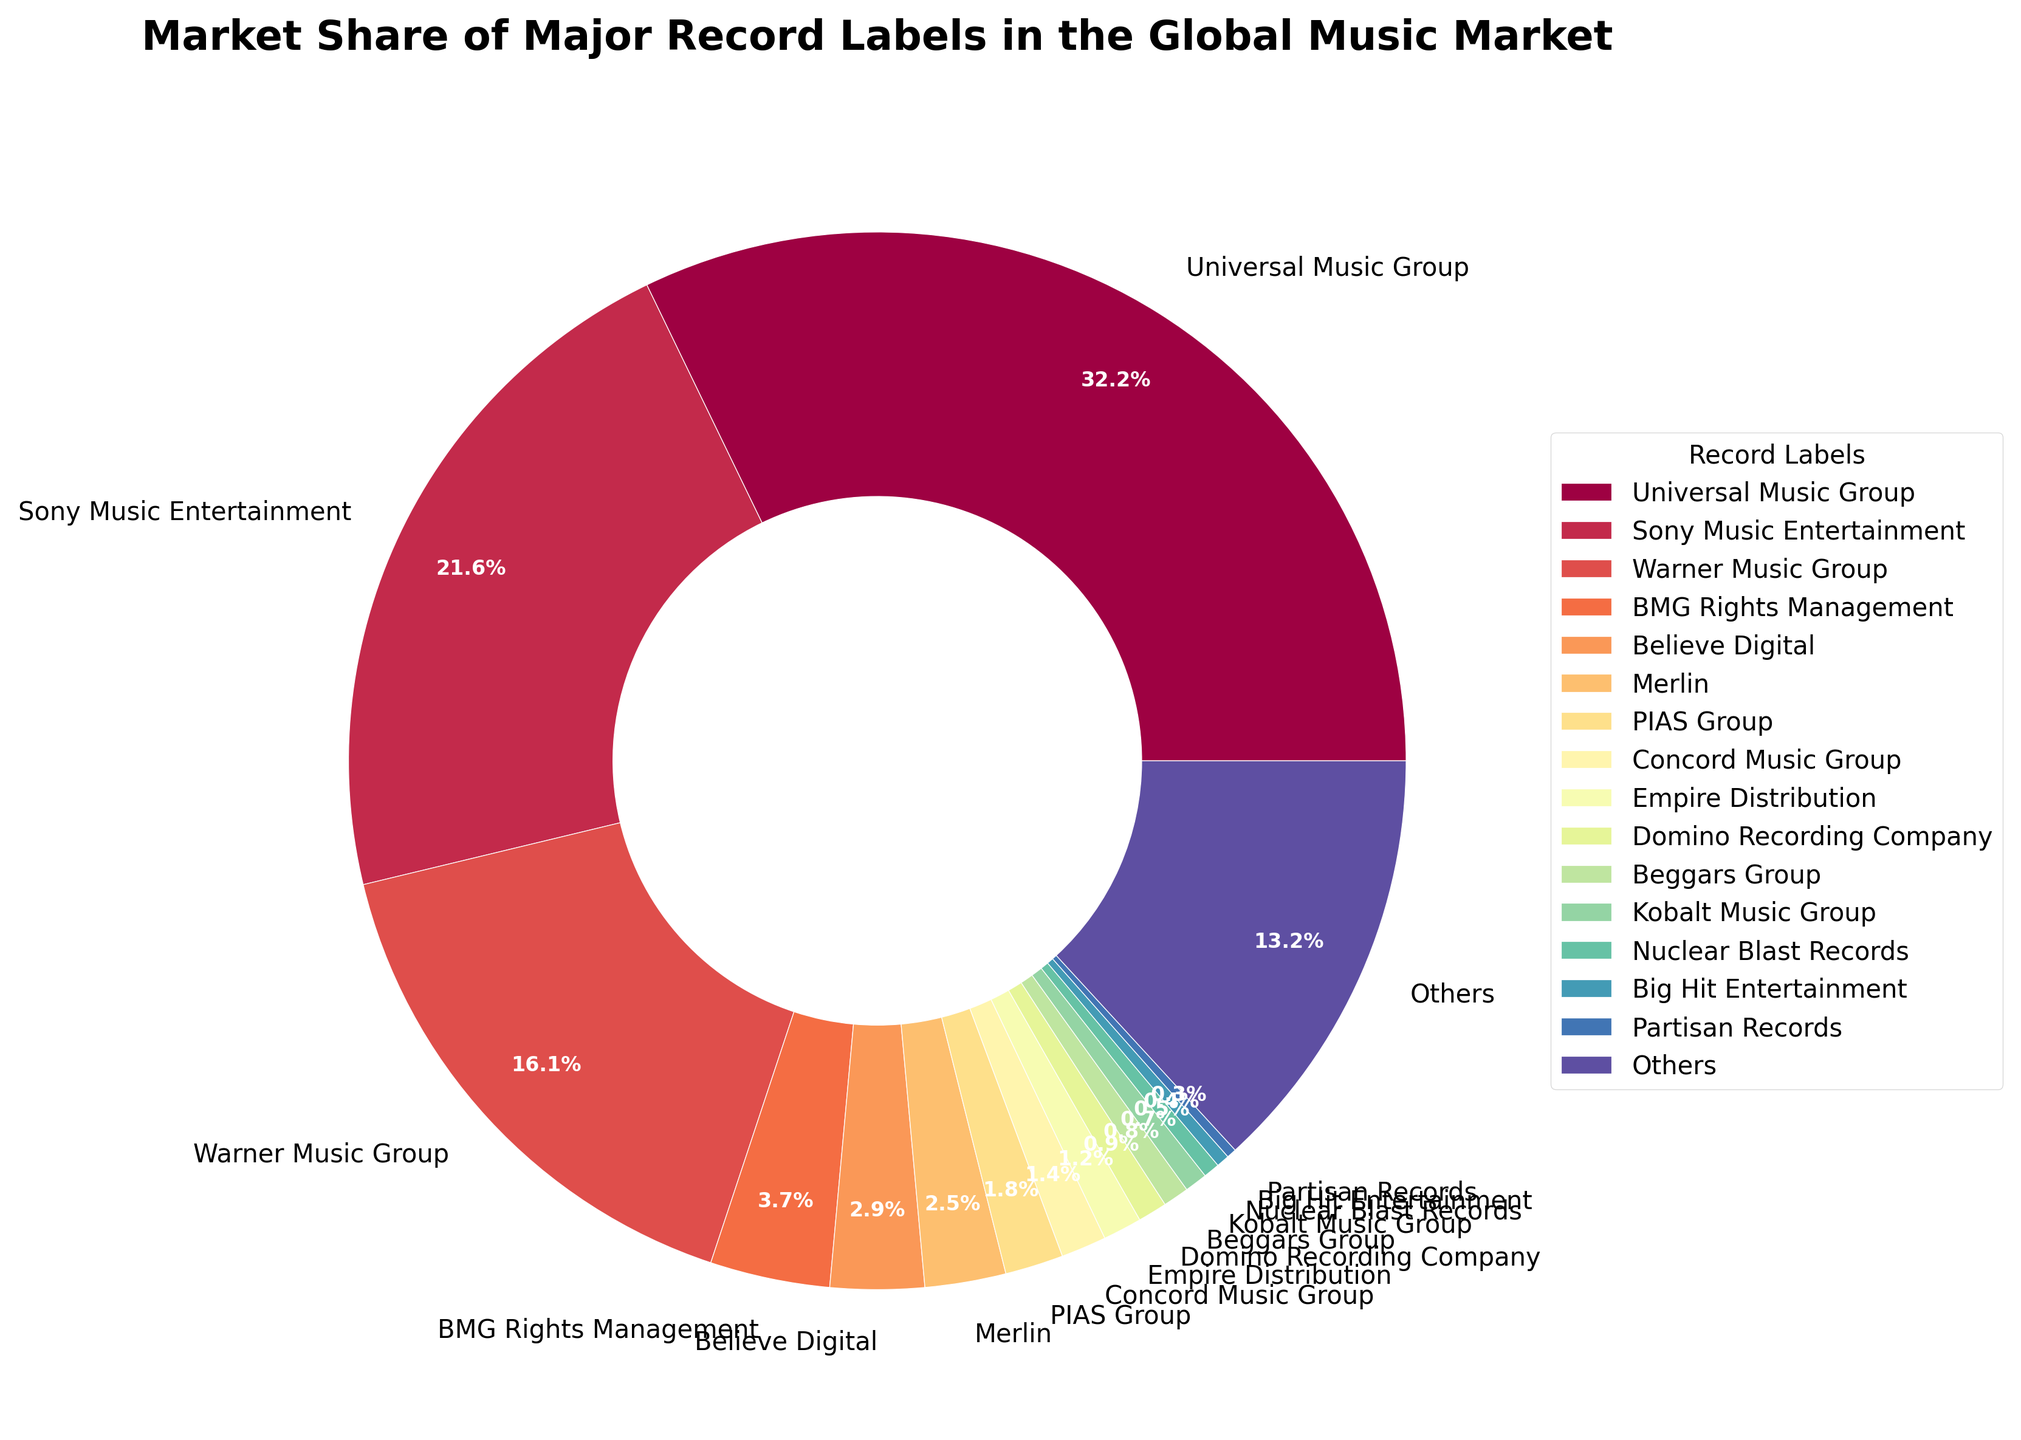What is the market share of the largest record label in the chart? The largest market share is represented by the slice of the pie that is the biggest, which corresponds to Universal Music Group. According to the given data, Universal Music Group has a 32.5% market share.
Answer: 32.5% Which record label has a larger market share: Warner Music Group or Sony Music Entertainment? Visually comparing the sizes of the wedges, the wedge representing Sony Music Entertainment is larger than that of Warner Music Group. According to the data, Sony Music Entertainment has a 21.8% share, and Warner Music Group has a 16.3% share.
Answer: Sony Music Entertainment What is the combined market share of BMG Rights Management and Believe Digital? Adding their market shares together: BMG Rights Management has 3.7% and Believe Digital has 2.9%. So, 3.7 + 2.9 = 6.6%.
Answer: 6.6% How much smaller is the market share of Merlin compared to Warner Music Group? Subtract the market share of Merlin from Warner Music Group: 16.3% - 2.5% = 13.8%.
Answer: 13.8% What percentage of the market do the three largest record labels (Universal Music Group, Sony Music Entertainment, and Warner Music Group) hold collectively? Adding the market shares of these three labels: 32.5% + 21.8% + 16.3% = 70.6%.
Answer: 70.6% Which record label has the smallest market share and what is it? The smallest wedge in the pie chart corresponds to Partisan Records with a market share of 0.3%.
Answer: Partisan Records, 0.3% How does the market share of 'Others' compare to that of BMG Rights Management? Comparing the wedges, 'Others' has a visibly larger market share than BMG Rights Management. 'Others' have a 13.3% market share, while BMG Rights Management has a 3.7% market share.
Answer: Others is larger What is the color of the segment representing Sony Music Entertainment? Each segment of the pie chart is colored differently; the color for Sony Music Entertainment's wedge would be visually identifiable.
Answer: Specific color from the chart (e.g., blue, orange, etc.) What is the average market share of the record labels excluding 'Others'? Summing all the market shares excluding 'Others' and then dividing by the number of these labels: (32.5 + 21.8 + 16.3 + 3.7 + 2.9 + 2.5 + 1.8 + 1.4 + 1.2 + 0.9 + 0.8 + 0.7 + 0.5 + 0.4 + 0.3) / 15 = 87.7 / 15 ≈ 5.85%.
Answer: 5.85% 